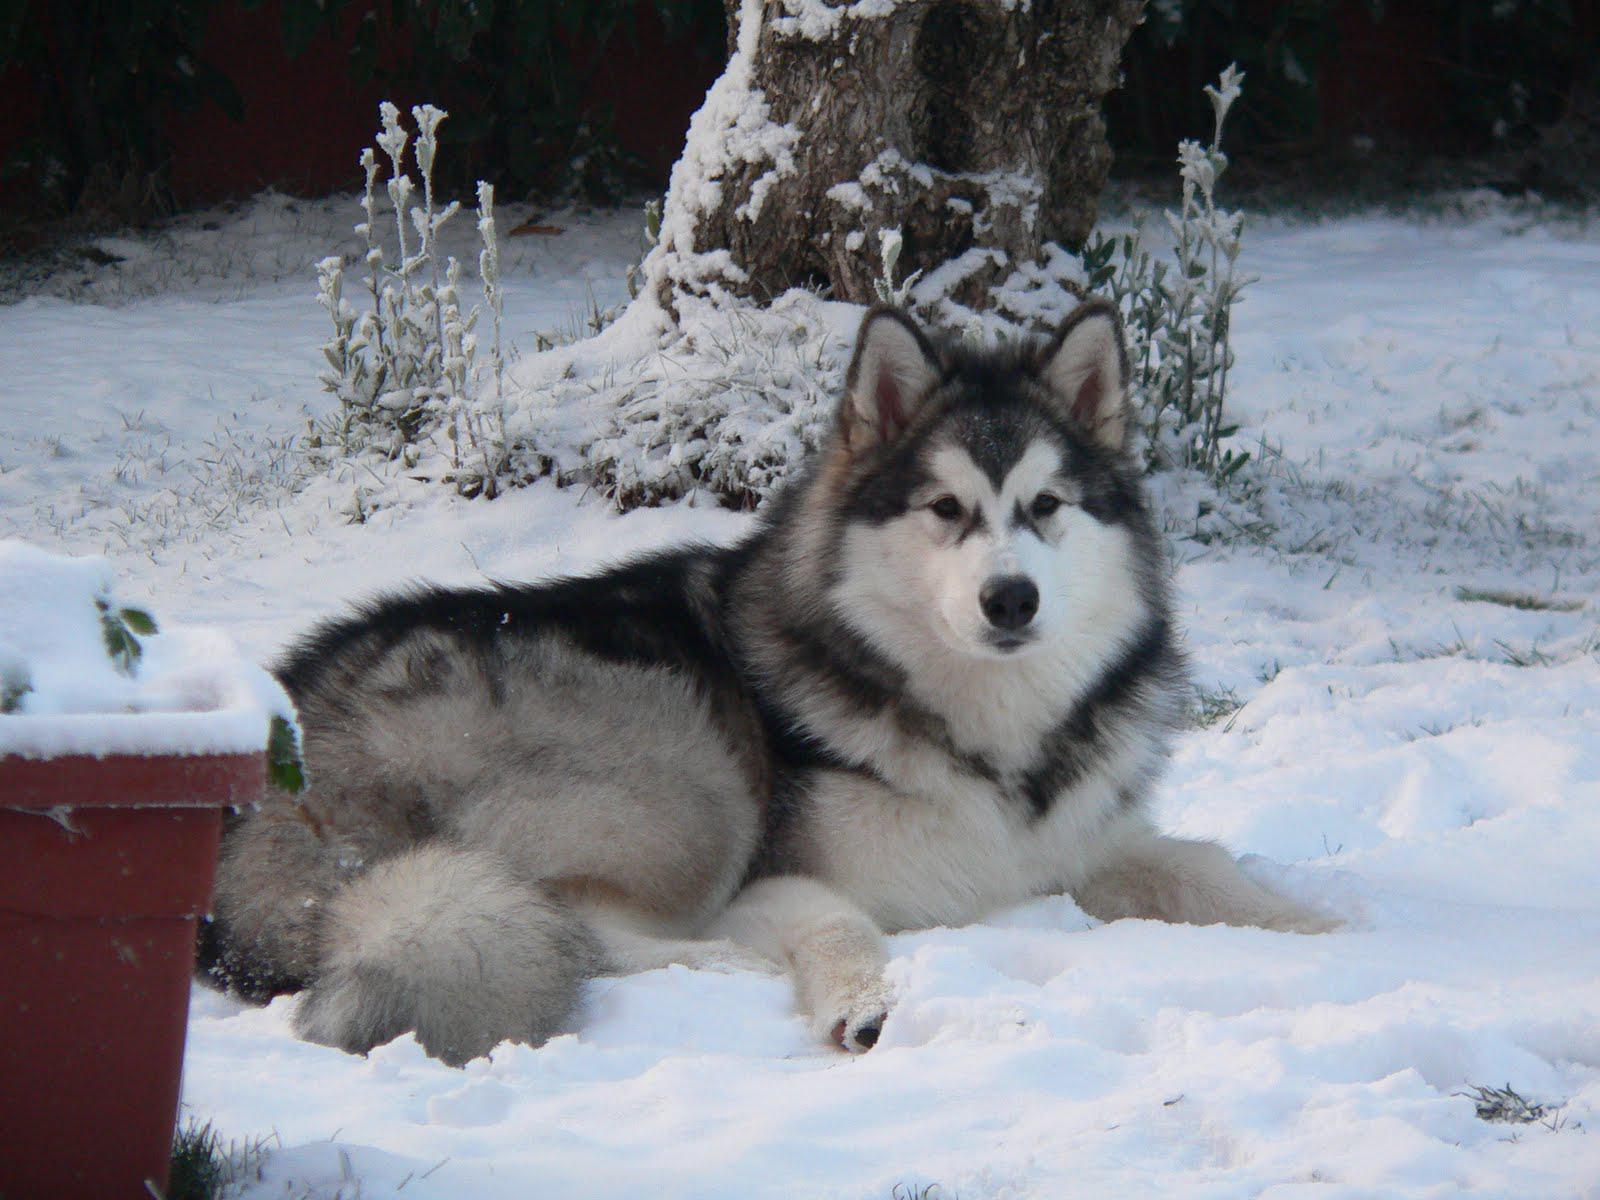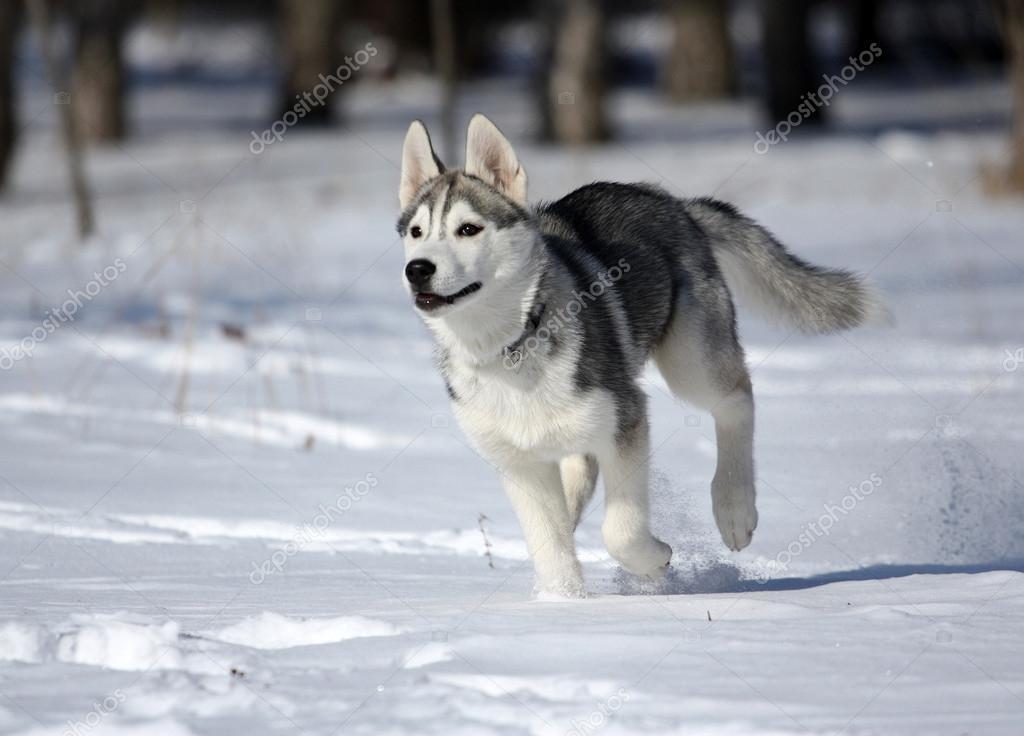The first image is the image on the left, the second image is the image on the right. Examine the images to the left and right. Is the description "All dogs are in snowy scenes, and the left image features a reclining black-and-white husky, while the right image features an upright husky." accurate? Answer yes or no. Yes. 